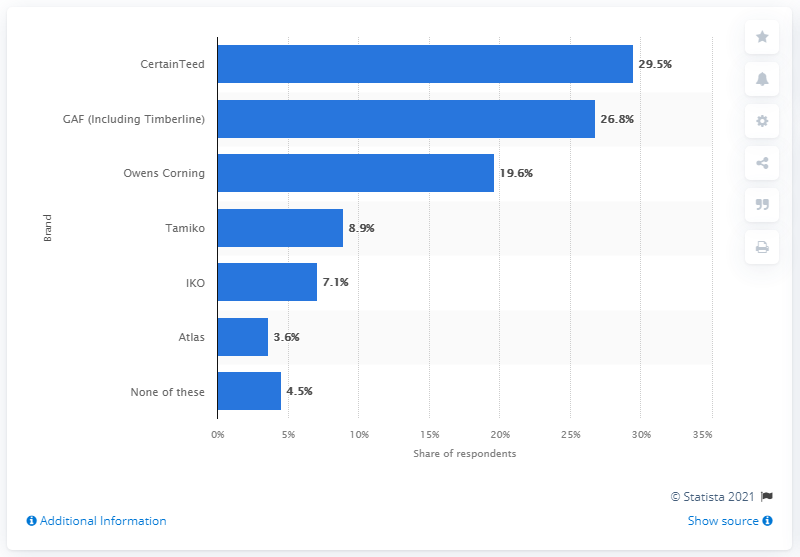Indicate a few pertinent items in this graphic. The most commonly used brand of asphalt/fiberglass shingles among respondents was CertainTeed, with 29.5% of respondents reporting this as their preferred choice. 